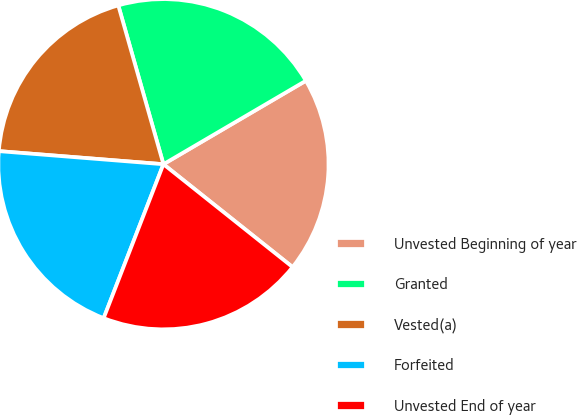<chart> <loc_0><loc_0><loc_500><loc_500><pie_chart><fcel>Unvested Beginning of year<fcel>Granted<fcel>Vested(a)<fcel>Forfeited<fcel>Unvested End of year<nl><fcel>19.14%<fcel>20.97%<fcel>19.33%<fcel>20.37%<fcel>20.19%<nl></chart> 